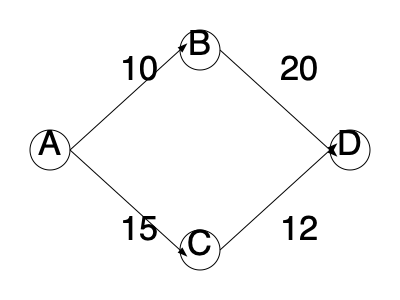Given the network diagram for a construction project, where the nodes represent milestones and the edge weights represent the duration (in days) of activities between milestones, what is the critical path and its total duration? To find the critical path and its duration, we need to follow these steps:

1. Identify all possible paths from start (A) to finish (D):
   Path 1: A -> B -> D
   Path 2: A -> C -> D

2. Calculate the duration of each path:
   Path 1: A -> B -> D
   Duration = 10 + 20 = 30 days

   Path 2: A -> C -> D
   Duration = 15 + 12 = 27 days

3. The critical path is the path with the longest duration, as it determines the minimum time required to complete the project.

4. Compare the durations:
   Path 1: 30 days
   Path 2: 27 days

5. The critical path is the longer path, which is Path 1: A -> B -> D.

6. The total duration of the critical path is 30 days.
Answer: A -> B -> D, 30 days 